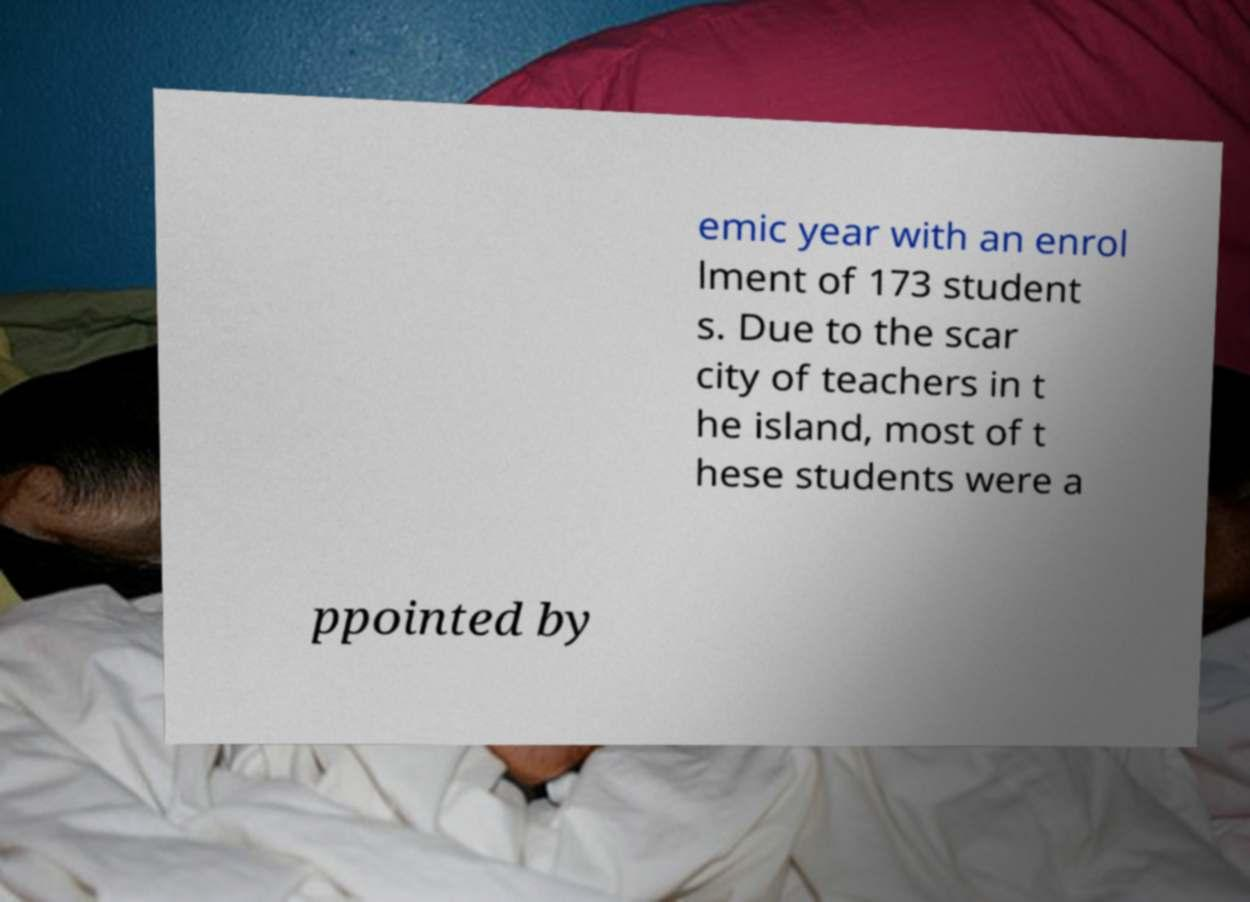Can you read and provide the text displayed in the image?This photo seems to have some interesting text. Can you extract and type it out for me? emic year with an enrol lment of 173 student s. Due to the scar city of teachers in t he island, most of t hese students were a ppointed by 